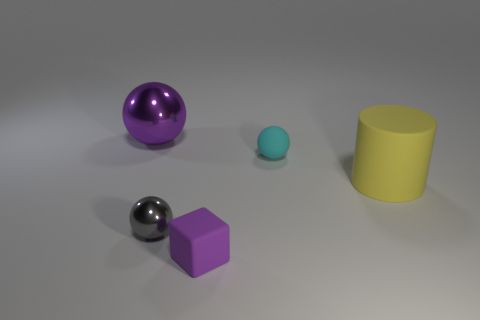Subtract all rubber balls. How many balls are left? 2 Subtract all cyan spheres. How many spheres are left? 2 Add 5 big spheres. How many objects exist? 10 Subtract 1 blocks. How many blocks are left? 0 Subtract all purple balls. Subtract all green blocks. How many balls are left? 2 Subtract all brown cubes. How many purple spheres are left? 1 Subtract all large purple balls. Subtract all small gray shiny objects. How many objects are left? 3 Add 2 cyan matte spheres. How many cyan matte spheres are left? 3 Add 1 tiny purple things. How many tiny purple things exist? 2 Subtract 0 red blocks. How many objects are left? 5 